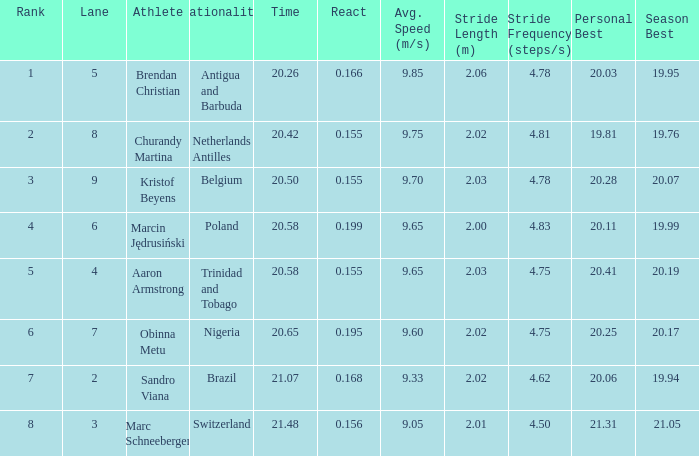Which Lane has a Time larger than 20.5, and a Nationality of trinidad and tobago? 4.0. 